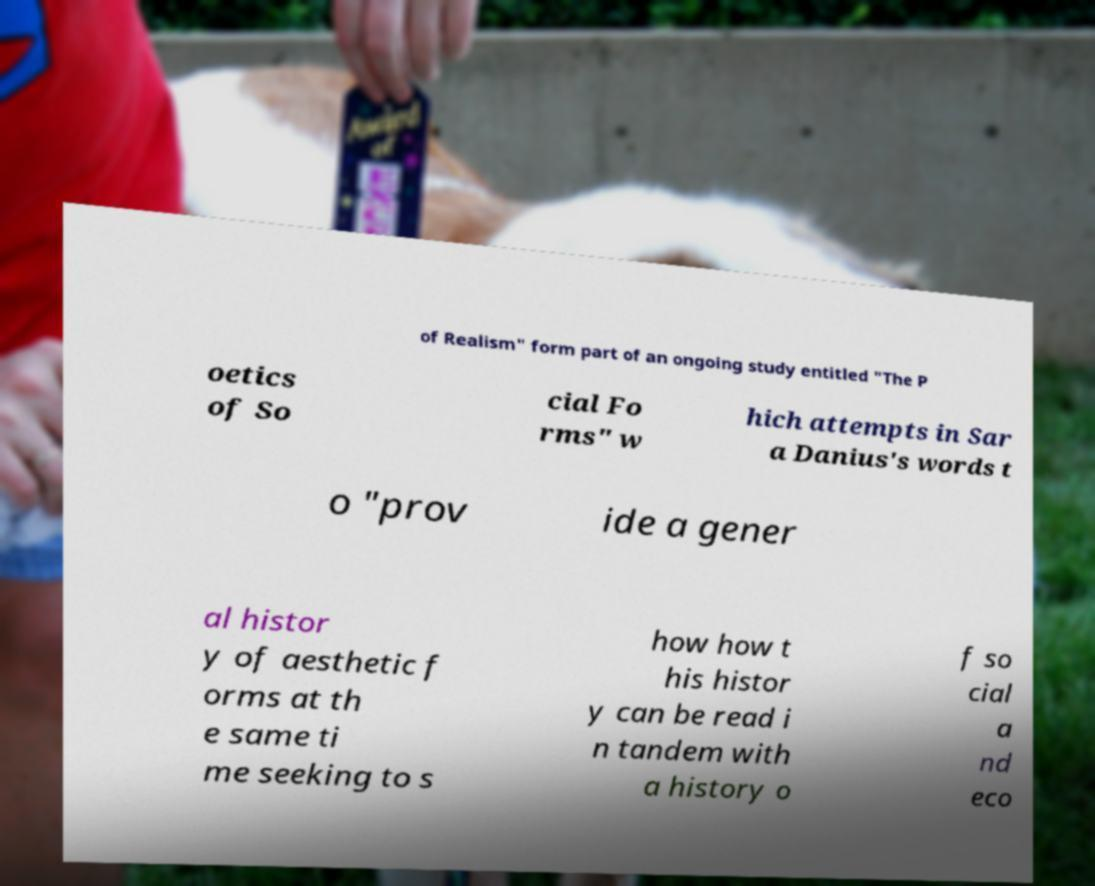I need the written content from this picture converted into text. Can you do that? of Realism" form part of an ongoing study entitled "The P oetics of So cial Fo rms" w hich attempts in Sar a Danius's words t o "prov ide a gener al histor y of aesthetic f orms at th e same ti me seeking to s how how t his histor y can be read i n tandem with a history o f so cial a nd eco 